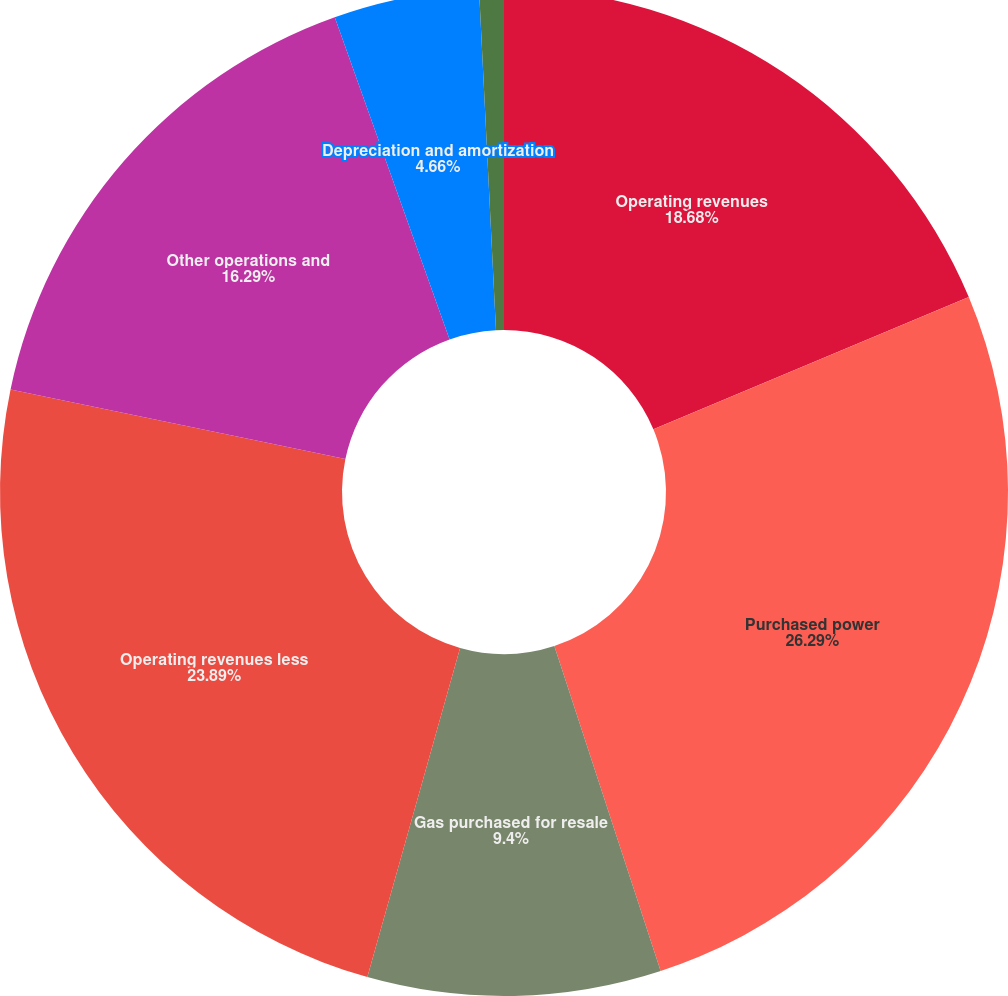<chart> <loc_0><loc_0><loc_500><loc_500><pie_chart><fcel>Operating revenues<fcel>Purchased power<fcel>Gas purchased for resale<fcel>Operating revenues less<fcel>Other operations and<fcel>Depreciation and amortization<fcel>Net interest expense<nl><fcel>18.68%<fcel>26.29%<fcel>9.4%<fcel>23.89%<fcel>16.29%<fcel>4.66%<fcel>0.79%<nl></chart> 